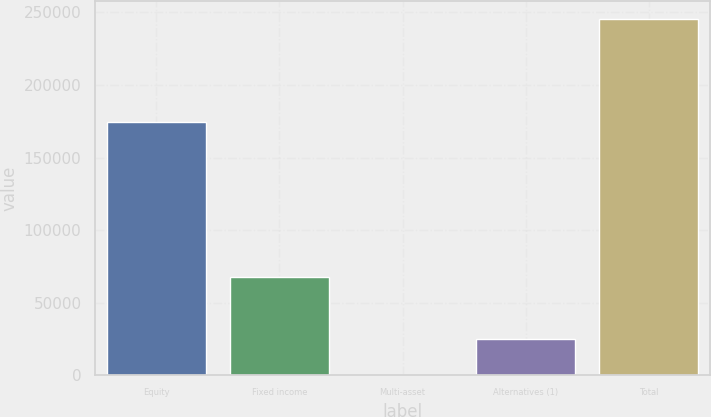<chart> <loc_0><loc_0><loc_500><loc_500><bar_chart><fcel>Equity<fcel>Fixed income<fcel>Multi-asset<fcel>Alternatives (1)<fcel>Total<nl><fcel>174377<fcel>67451<fcel>322<fcel>24824<fcel>245342<nl></chart> 